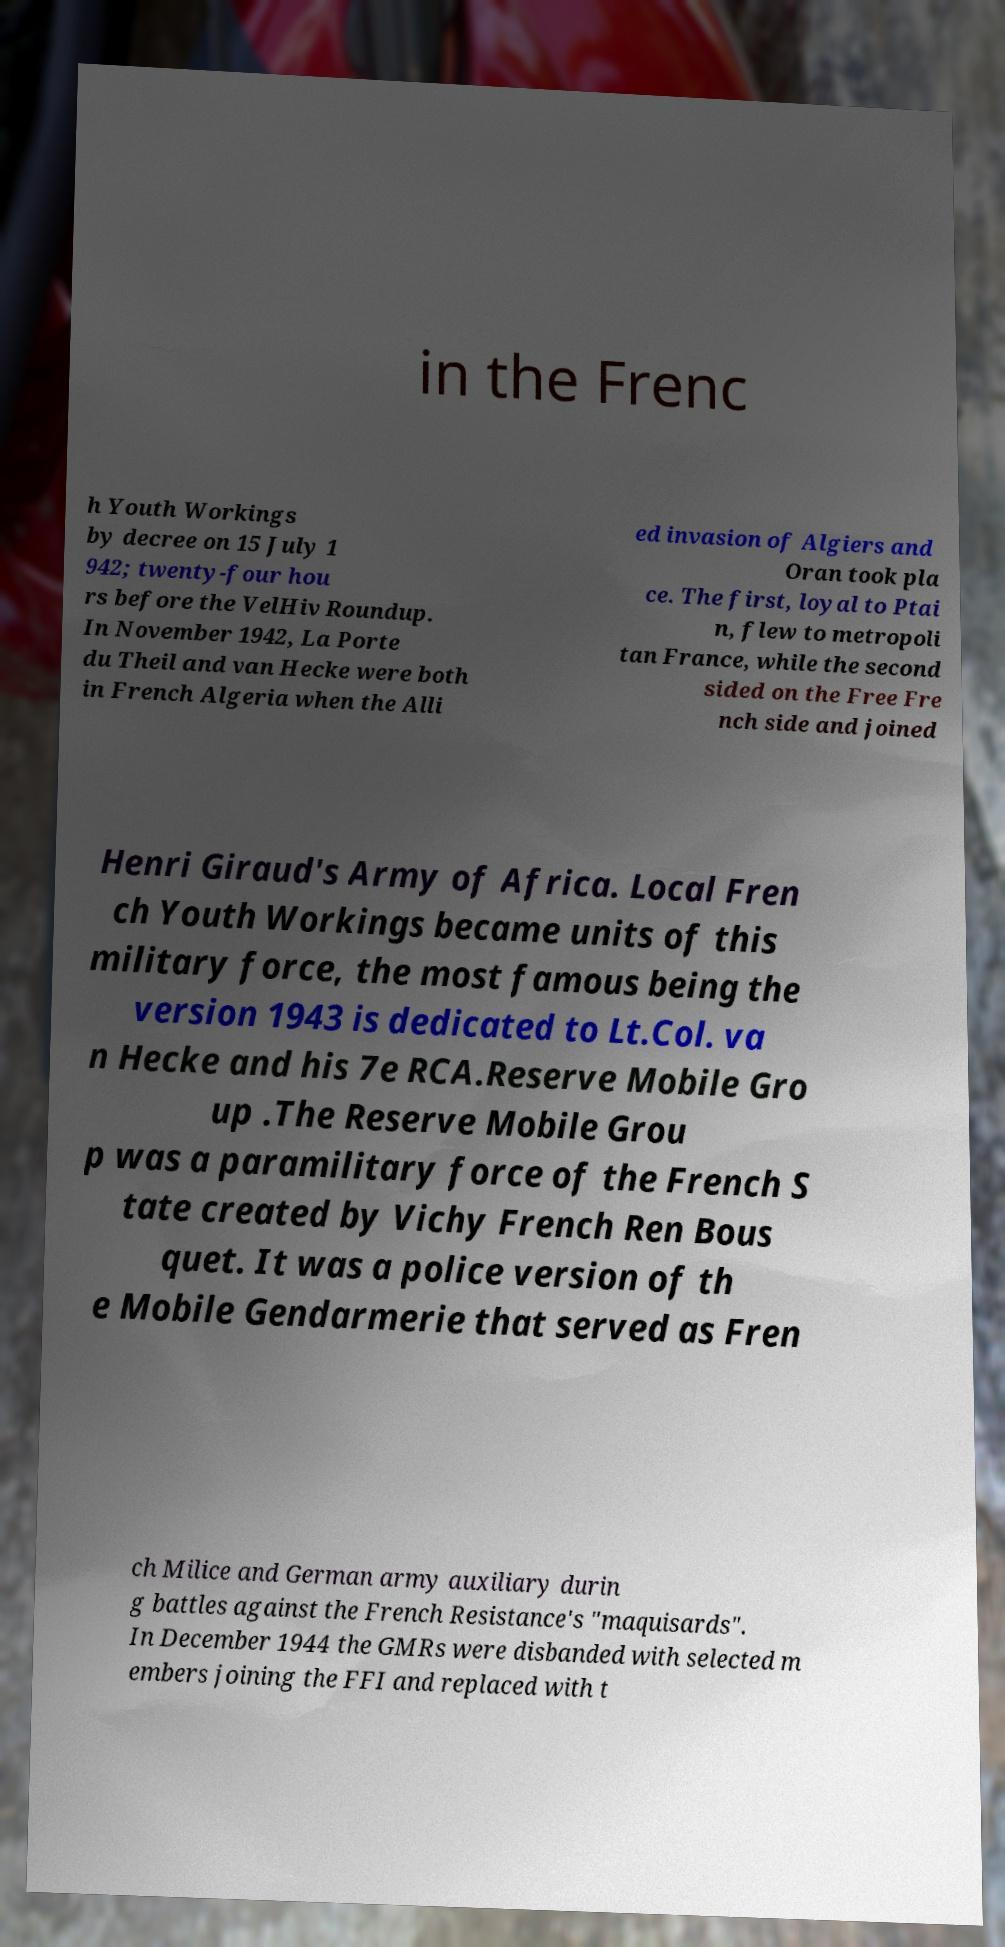Could you assist in decoding the text presented in this image and type it out clearly? in the Frenc h Youth Workings by decree on 15 July 1 942; twenty-four hou rs before the VelHiv Roundup. In November 1942, La Porte du Theil and van Hecke were both in French Algeria when the Alli ed invasion of Algiers and Oran took pla ce. The first, loyal to Ptai n, flew to metropoli tan France, while the second sided on the Free Fre nch side and joined Henri Giraud's Army of Africa. Local Fren ch Youth Workings became units of this military force, the most famous being the version 1943 is dedicated to Lt.Col. va n Hecke and his 7e RCA.Reserve Mobile Gro up .The Reserve Mobile Grou p was a paramilitary force of the French S tate created by Vichy French Ren Bous quet. It was a police version of th e Mobile Gendarmerie that served as Fren ch Milice and German army auxiliary durin g battles against the French Resistance's "maquisards". In December 1944 the GMRs were disbanded with selected m embers joining the FFI and replaced with t 